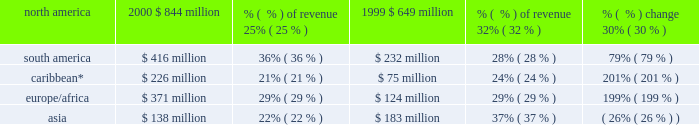The breakdown of aes 2019s gross margin for the years ended december 31 , 2000 and 1999 , based on the geographic region in which they were earned , is set forth below. .
* includes venezuela and colombia .
Selling , general and administrative expenses selling , general and administrative expenses increased $ 11 million , or 15% ( 15 % ) , to $ 82 million in 2000 from $ 71 million in 1999 .
Selling , general and administrative expenses as a percentage of revenues remained constant at 1% ( 1 % ) in both 2000 and 1999 .
The increase is due to an increase in business development activities .
Interest expense , net net interest expense increased $ 506 million , or 80% ( 80 % ) , to $ 1.1 billion in 2000 from $ 632 million in 1999 .
Interest expense as a percentage of revenues remained constant at 15% ( 15 % ) in both 2000 and 1999 .
Interest expense increased primarily due to the interest at new businesses , including drax , tiete , cilcorp and edc , as well as additional corporate interest costs resulting from the senior debt and convertible securities issued within the past two years .
Other income , net other income increased $ 16 million , or 107% ( 107 % ) , to $ 31 million in 2000 from $ 15 million in 1999 .
Other income includes foreign currency transaction gains and losses as well as other non-operating income .
The increase in other income is due primarily to a favorable legal judgment and the sale of development projects .
Severance and transaction costs during the fourth quarter of 2000 , the company incurred approximately $ 79 million of transaction and contractual severance costs related to the acquisition of ipalco .
Gain on sale of assets during 2000 , ipalco sold certain assets ( 2018 2018thermal assets 2019 2019 ) for approximately $ 162 million .
The transaction resulted in a gain to the company of approximately $ 31 million .
Of the net proceeds , $ 88 million was used to retire debt specifically assignable to the thermal assets .
During 1999 , the company recorded a $ 29 million gain ( before extraordinary loss ) from the buyout of its long-term power sales agreement at placerita .
The company received gross proceeds of $ 110 million which were offset by transaction related costs of $ 19 million and an impairment loss of $ 62 million to reduce the carrying value of the electric generation assets to their estimated fair value after termination of the contract .
The estimated fair value was determined by an independent appraisal .
Concurrent with the buyout of the power sales agreement , the company repaid the related non-recourse debt prior to its scheduled maturity and recorded an extraordinary loss of $ 11 million , net of income taxes. .
What was the gross margin change in basis points for south america? 
Computations: ((36% - 28%) * 1000)
Answer: 80.0. 